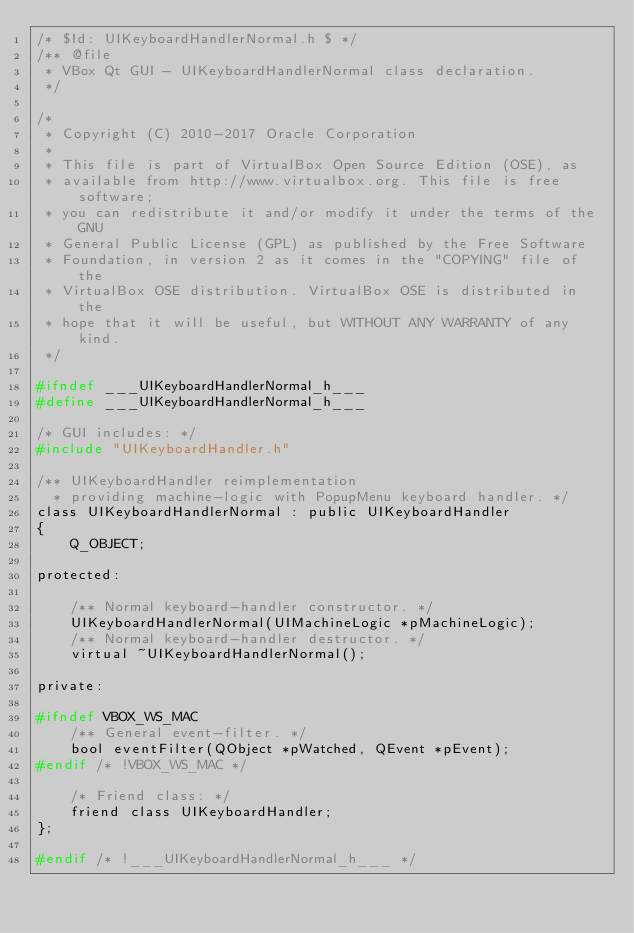Convert code to text. <code><loc_0><loc_0><loc_500><loc_500><_C_>/* $Id: UIKeyboardHandlerNormal.h $ */
/** @file
 * VBox Qt GUI - UIKeyboardHandlerNormal class declaration.
 */

/*
 * Copyright (C) 2010-2017 Oracle Corporation
 *
 * This file is part of VirtualBox Open Source Edition (OSE), as
 * available from http://www.virtualbox.org. This file is free software;
 * you can redistribute it and/or modify it under the terms of the GNU
 * General Public License (GPL) as published by the Free Software
 * Foundation, in version 2 as it comes in the "COPYING" file of the
 * VirtualBox OSE distribution. VirtualBox OSE is distributed in the
 * hope that it will be useful, but WITHOUT ANY WARRANTY of any kind.
 */

#ifndef ___UIKeyboardHandlerNormal_h___
#define ___UIKeyboardHandlerNormal_h___

/* GUI includes: */
#include "UIKeyboardHandler.h"

/** UIKeyboardHandler reimplementation
  * providing machine-logic with PopupMenu keyboard handler. */
class UIKeyboardHandlerNormal : public UIKeyboardHandler
{
    Q_OBJECT;

protected:

    /** Normal keyboard-handler constructor. */
    UIKeyboardHandlerNormal(UIMachineLogic *pMachineLogic);
    /** Normal keyboard-handler destructor. */
    virtual ~UIKeyboardHandlerNormal();

private:

#ifndef VBOX_WS_MAC
    /** General event-filter. */
    bool eventFilter(QObject *pWatched, QEvent *pEvent);
#endif /* !VBOX_WS_MAC */

    /* Friend class: */
    friend class UIKeyboardHandler;
};

#endif /* !___UIKeyboardHandlerNormal_h___ */
</code> 